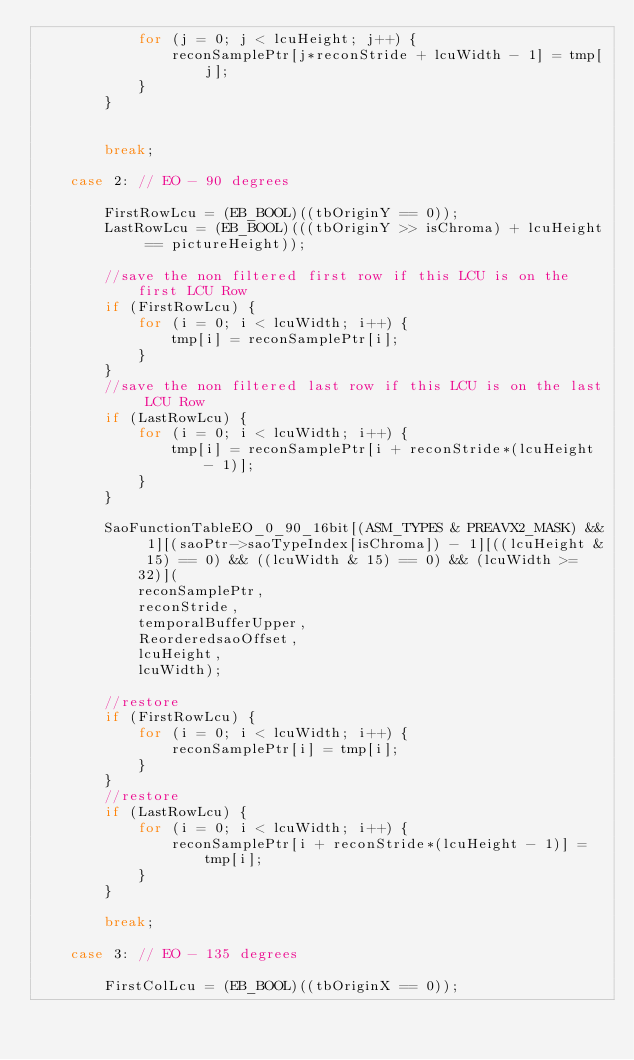<code> <loc_0><loc_0><loc_500><loc_500><_C_>            for (j = 0; j < lcuHeight; j++) {
                reconSamplePtr[j*reconStride + lcuWidth - 1] = tmp[j];
            }
        }


        break;

    case 2: // EO - 90 degrees

        FirstRowLcu = (EB_BOOL)((tbOriginY == 0));
        LastRowLcu = (EB_BOOL)(((tbOriginY >> isChroma) + lcuHeight == pictureHeight));

        //save the non filtered first row if this LCU is on the first LCU Row
        if (FirstRowLcu) {
            for (i = 0; i < lcuWidth; i++) {
                tmp[i] = reconSamplePtr[i];
            }
        }
        //save the non filtered last row if this LCU is on the last LCU Row
        if (LastRowLcu) {
            for (i = 0; i < lcuWidth; i++) {
                tmp[i] = reconSamplePtr[i + reconStride*(lcuHeight - 1)];
            }
        }

        SaoFunctionTableEO_0_90_16bit[(ASM_TYPES & PREAVX2_MASK) && 1][(saoPtr->saoTypeIndex[isChroma]) - 1][((lcuHeight & 15) == 0) && ((lcuWidth & 15) == 0) && (lcuWidth >= 32)](
            reconSamplePtr,
            reconStride,
            temporalBufferUpper,
            ReorderedsaoOffset,
            lcuHeight,
            lcuWidth);

        //restore
        if (FirstRowLcu) {
            for (i = 0; i < lcuWidth; i++) {
                reconSamplePtr[i] = tmp[i];
            }
        }
        //restore
        if (LastRowLcu) {
            for (i = 0; i < lcuWidth; i++) {
                reconSamplePtr[i + reconStride*(lcuHeight - 1)] = tmp[i];
            }
        }

        break;

    case 3: // EO - 135 degrees

        FirstColLcu = (EB_BOOL)((tbOriginX == 0));</code> 